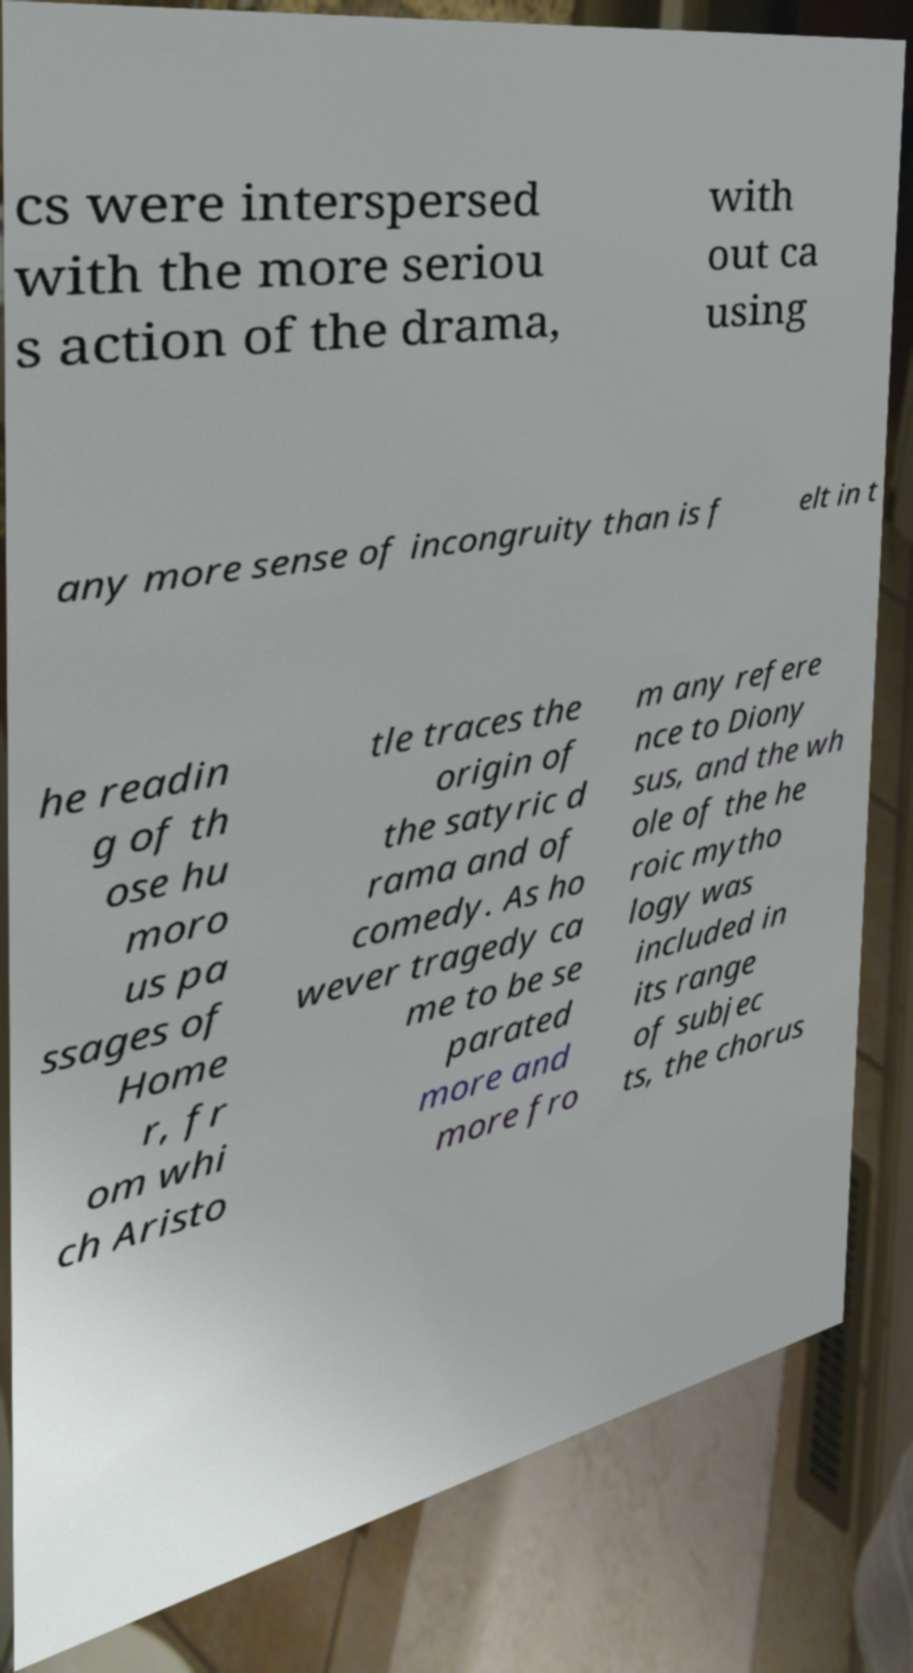Please read and relay the text visible in this image. What does it say? cs were interspersed with the more seriou s action of the drama, with out ca using any more sense of incongruity than is f elt in t he readin g of th ose hu moro us pa ssages of Home r, fr om whi ch Aristo tle traces the origin of the satyric d rama and of comedy. As ho wever tragedy ca me to be se parated more and more fro m any refere nce to Diony sus, and the wh ole of the he roic mytho logy was included in its range of subjec ts, the chorus 